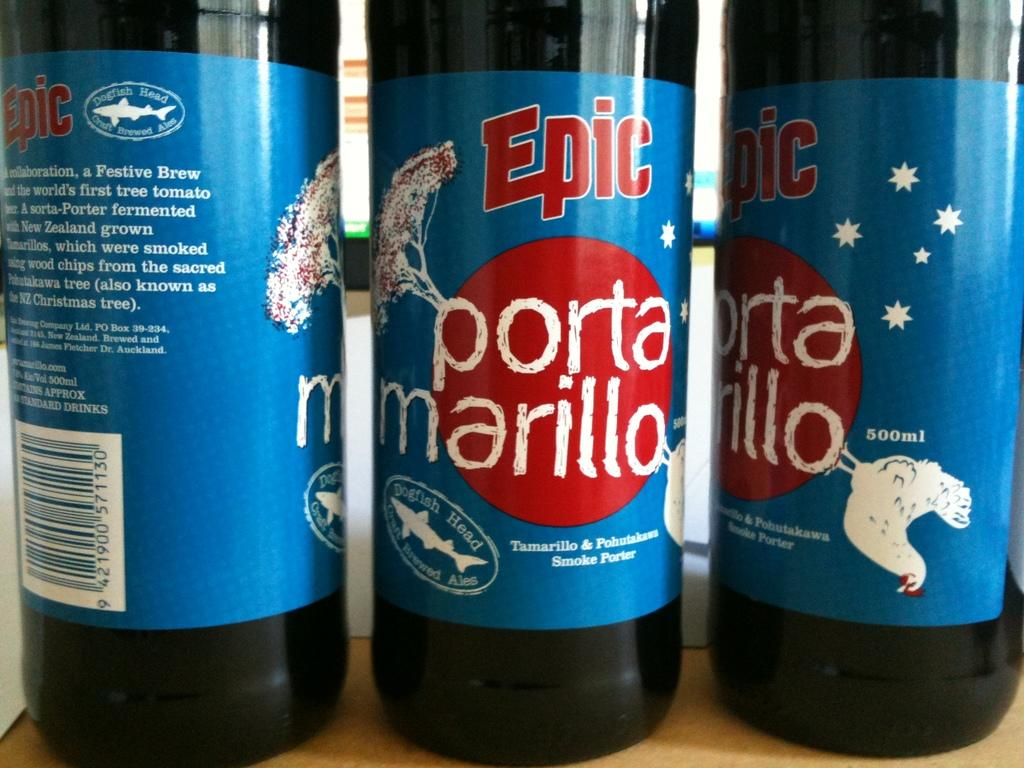<image>
Render a clear and concise summary of the photo. three bottles standing next to each other that are labeled 'epic porta marillo' 